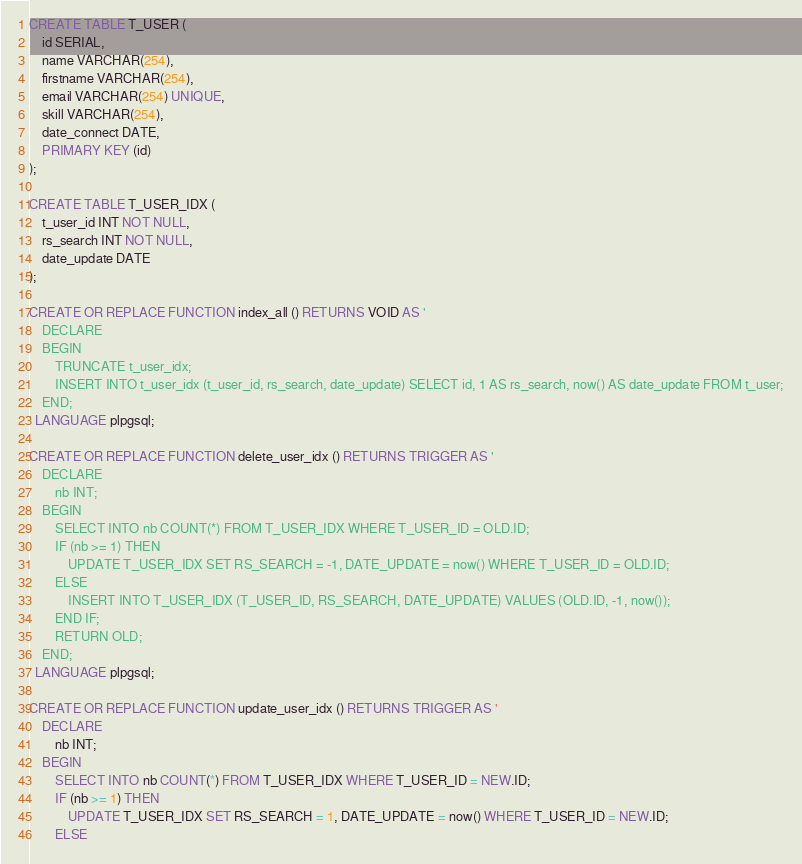Convert code to text. <code><loc_0><loc_0><loc_500><loc_500><_SQL_>CREATE TABLE T_USER (
	id SERIAL,
	name VARCHAR(254), 
	firstname VARCHAR(254), 
	email VARCHAR(254) UNIQUE,
	skill VARCHAR(254),
	date_connect DATE,
	PRIMARY KEY (id)
);

CREATE TABLE T_USER_IDX (
	t_user_id INT NOT NULL,
	rs_search INT NOT NULL,
	date_update DATE
);

CREATE OR REPLACE FUNCTION index_all () RETURNS VOID AS '
    DECLARE
    BEGIN 
        TRUNCATE t_user_idx;
        INSERT INTO t_user_idx (t_user_id, rs_search, date_update) SELECT id, 1 AS rs_search, now() AS date_update FROM t_user;
    END; 
' LANGUAGE plpgsql;

CREATE OR REPLACE FUNCTION delete_user_idx () RETURNS TRIGGER AS '
    DECLARE 
        nb INT; 
    BEGIN 
        SELECT INTO nb COUNT(*) FROM T_USER_IDX WHERE T_USER_ID = OLD.ID; 
        IF (nb >= 1) THEN 
            UPDATE T_USER_IDX SET RS_SEARCH = -1, DATE_UPDATE = now() WHERE T_USER_ID = OLD.ID;
        ELSE
            INSERT INTO T_USER_IDX (T_USER_ID, RS_SEARCH, DATE_UPDATE) VALUES (OLD.ID, -1, now());
        END IF; 
        RETURN OLD; 
    END;
' LANGUAGE plpgsql;

CREATE OR REPLACE FUNCTION update_user_idx () RETURNS TRIGGER AS '
    DECLARE 
        nb INT; 
    BEGIN 
        SELECT INTO nb COUNT(*) FROM T_USER_IDX WHERE T_USER_ID = NEW.ID; 
        IF (nb >= 1) THEN 
            UPDATE T_USER_IDX SET RS_SEARCH = 1, DATE_UPDATE = now() WHERE T_USER_ID = NEW.ID;
        ELSE</code> 